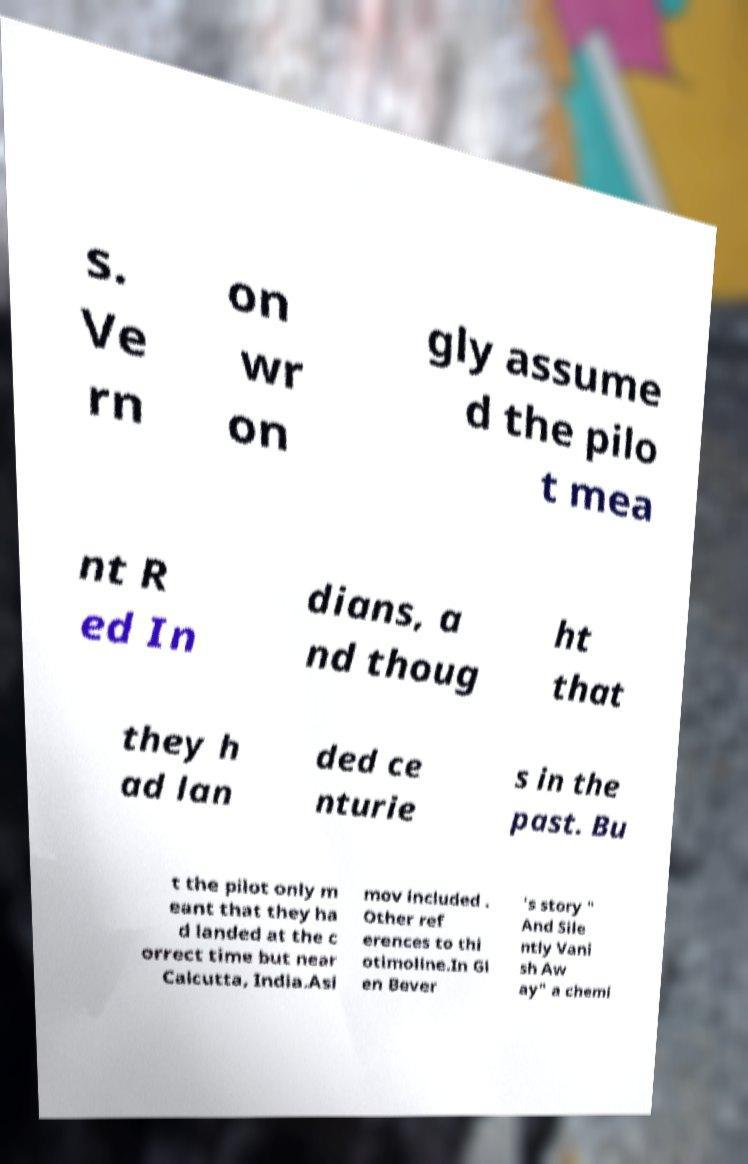Please read and relay the text visible in this image. What does it say? s. Ve rn on wr on gly assume d the pilo t mea nt R ed In dians, a nd thoug ht that they h ad lan ded ce nturie s in the past. Bu t the pilot only m eant that they ha d landed at the c orrect time but near Calcutta, India.Asi mov included . Other ref erences to thi otimoline.In Gl en Bever 's story " And Sile ntly Vani sh Aw ay" a chemi 